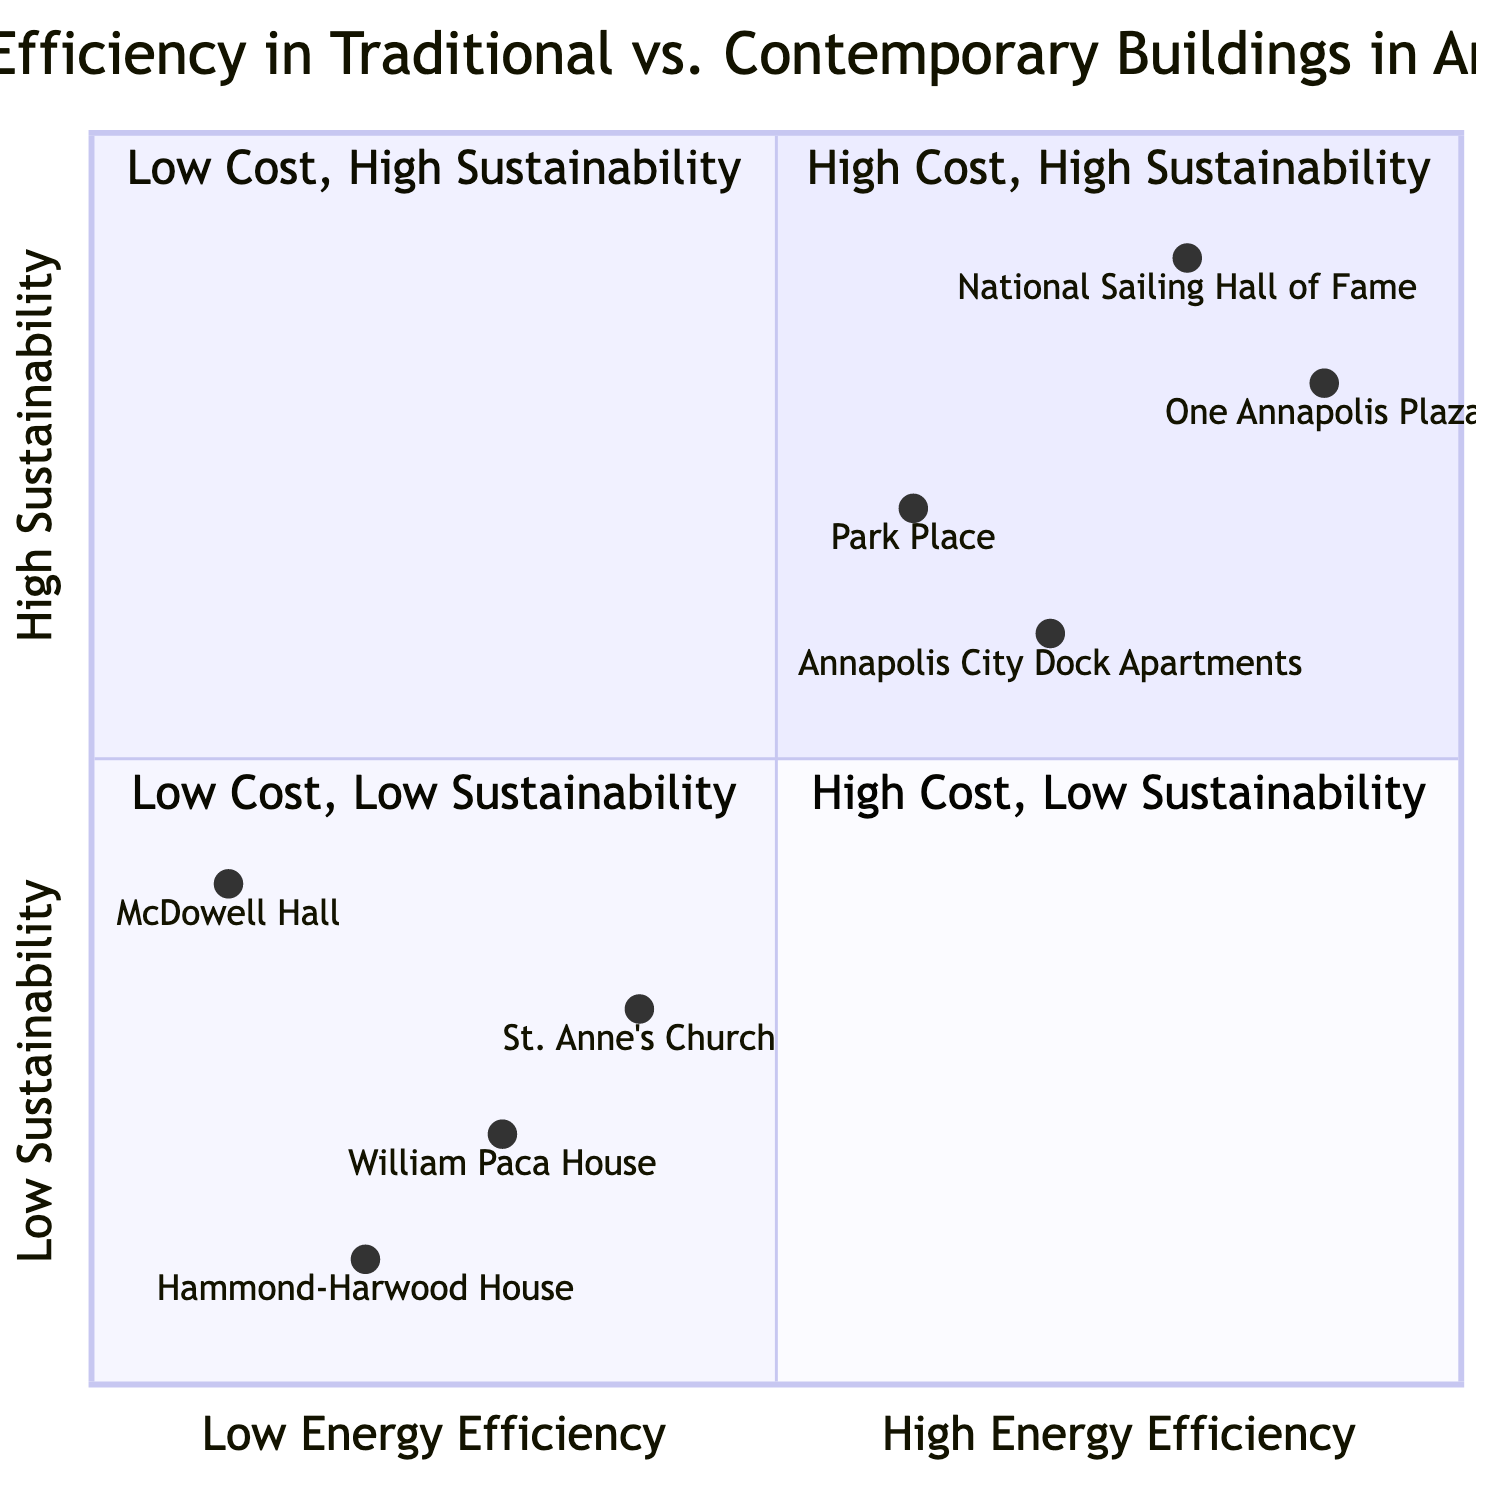What is the average energy use per square foot of the William Paca House? Referring to the diagram, the William Paca House is categorized under Traditional buildings and has an average energy use of 68 kWh per square foot.
Answer: 68 kWh Which building has a higher peak energy use: Annapolis City Dock Apartments or One Annapolis Plaza? The peak energy use for Annapolis City Dock Apartments is 70 kWh, while the data for One Annapolis Plaza does not explicitly state the peak energy use in the provided data. Thus, we can ascertain that Annapolis City Dock Apartments has a stated peak energy use, and no value was provided for One Annapolis Plaza for comparison.
Answer: 70 kWh In terms of sustainability measures, which building uses solar panels? The National Sailing Hall of Fame is identified as having solar panels installed, while St. Anne's Church does not.
Answer: National Sailing Hall of Fame What are the initial costs for the Hammond-Harwood House? The Hammond-Harwood House has an initial cost labeled as $2 million, as noted in the costs quadrant of the diagram.
Answer: $2 million Which building is located in the high sustainability and low energy efficiency quadrant? The diagram shows McDowell Hall, which is noted as having low energy efficiency (0.1) and a moderate sustainability score (0.4), placing it in this specific quadrant.
Answer: McDowell Hall What is the maintenance cost of One Annapolis Plaza? According to the data for One Annapolis Plaza, it has an annual maintenance cost of $500,000.
Answer: $500,000 Which building has the lowest energy consumption per square foot? Among the entities listed, the Annapolis City Dock Apartments have the lowest average energy use per square foot at 50 kWh, compared to the others in the diagram.
Answer: 50 kWh Which building represents high initial costs along with high sustainability? The One Annapolis Plaza, with initial costs of $25 million and a high sustainability score, represents this combination in the diagram.
Answer: One Annapolis Plaza How many buildings are represented in the quadrant of low cost and low sustainability? The quadrant of low cost and low sustainability contains only one building, which is the Hammond-Harwood House.
Answer: 1 